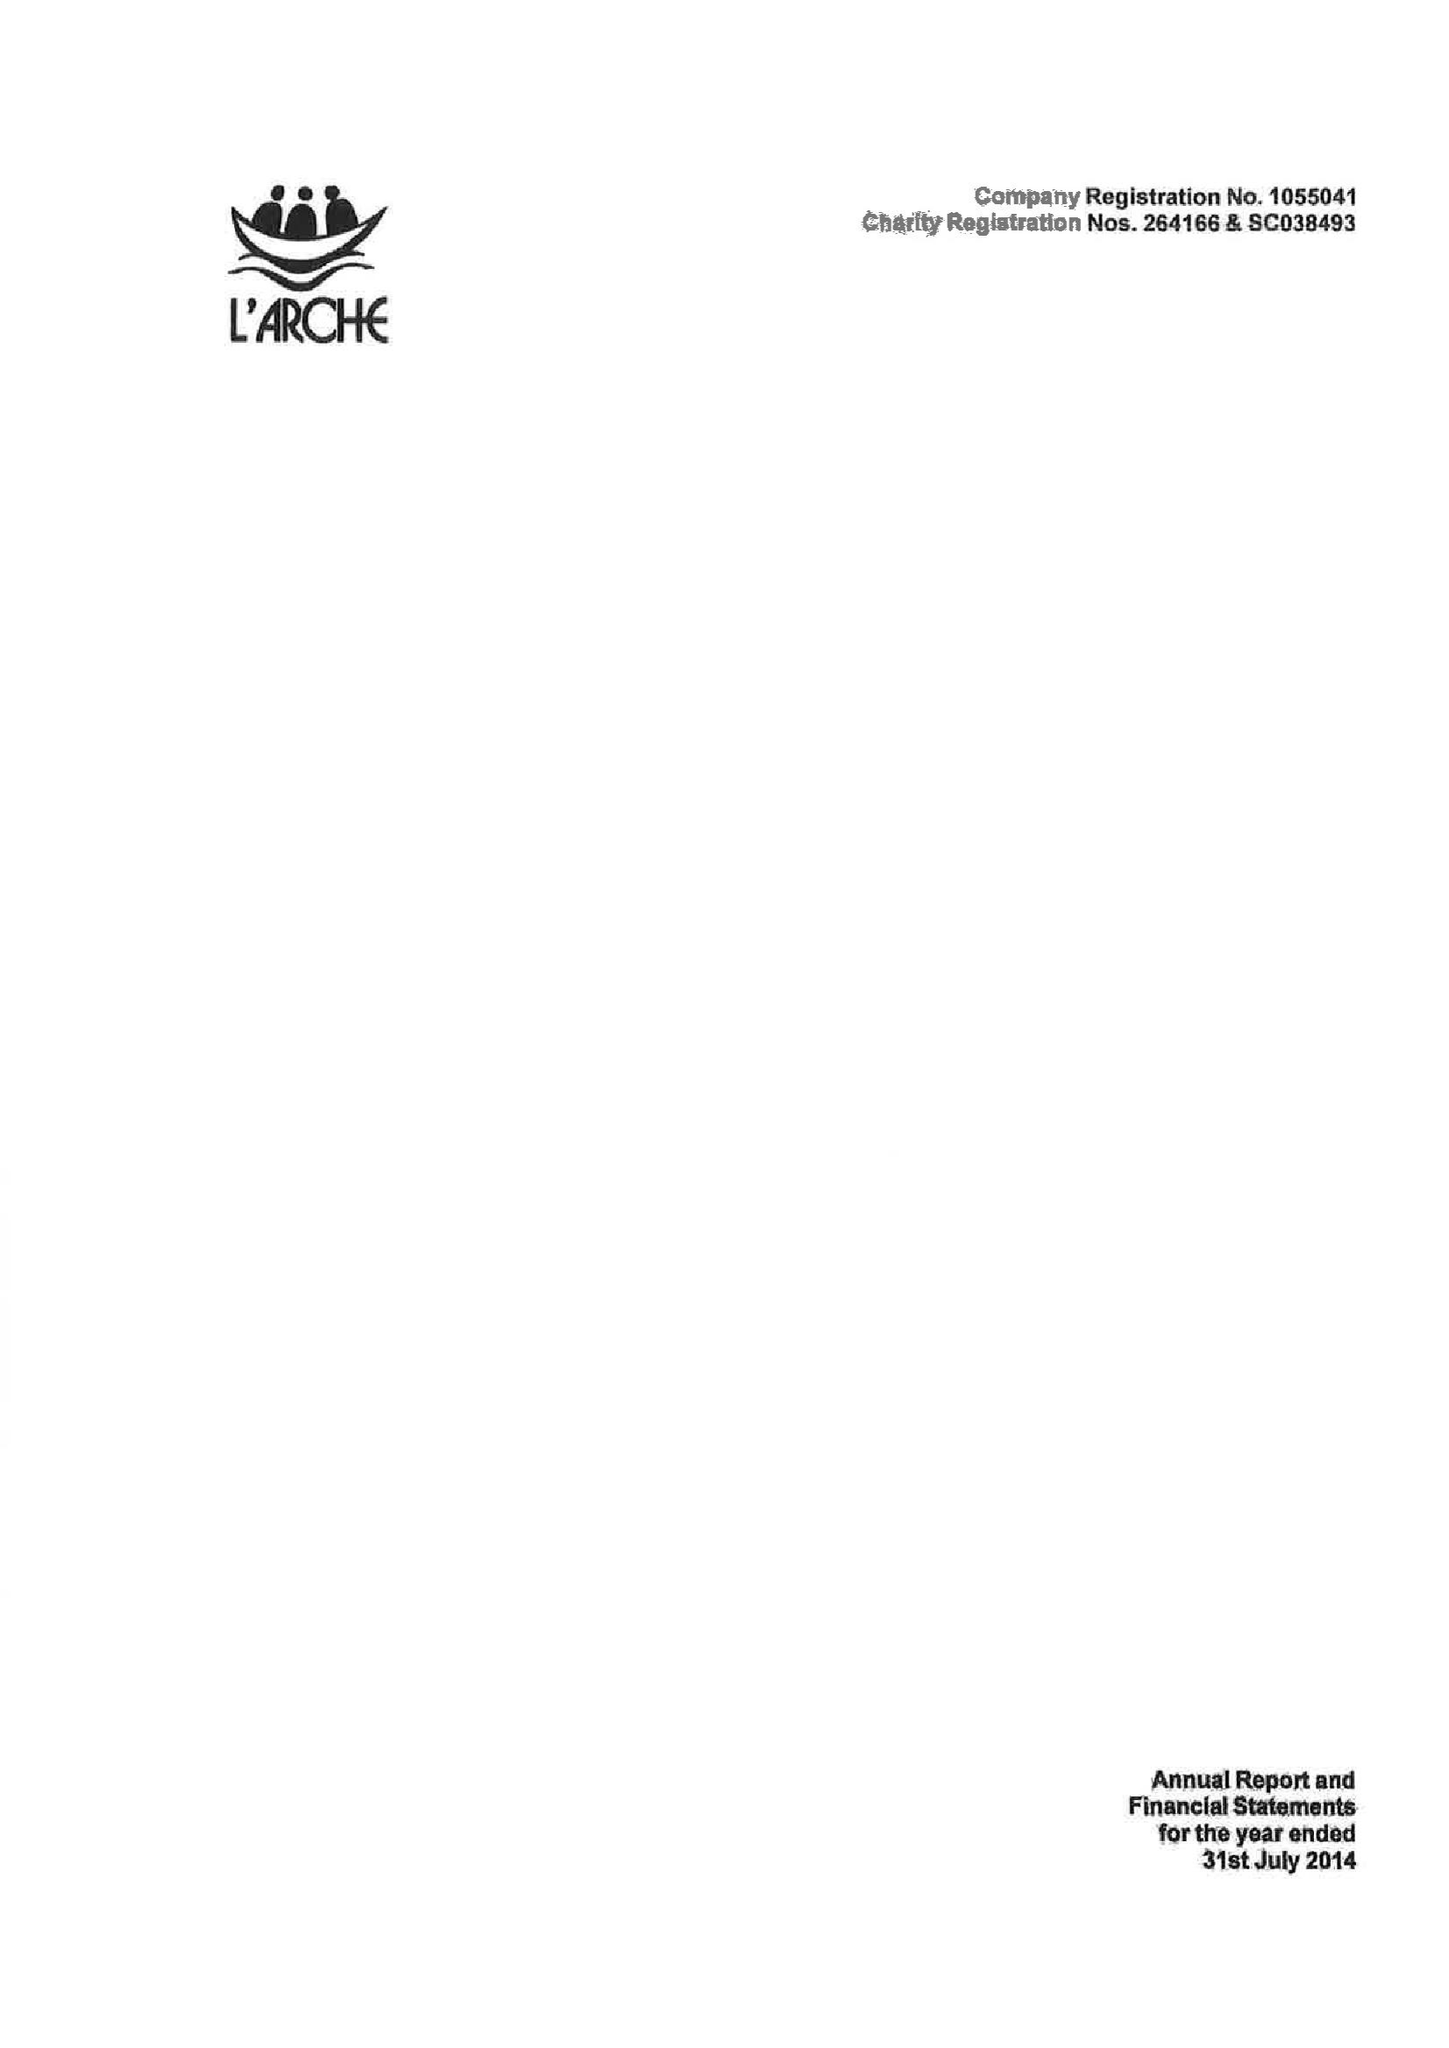What is the value for the report_date?
Answer the question using a single word or phrase. 2014-07-31 